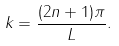<formula> <loc_0><loc_0><loc_500><loc_500>k = \frac { ( 2 n + 1 ) \pi } { L } .</formula> 